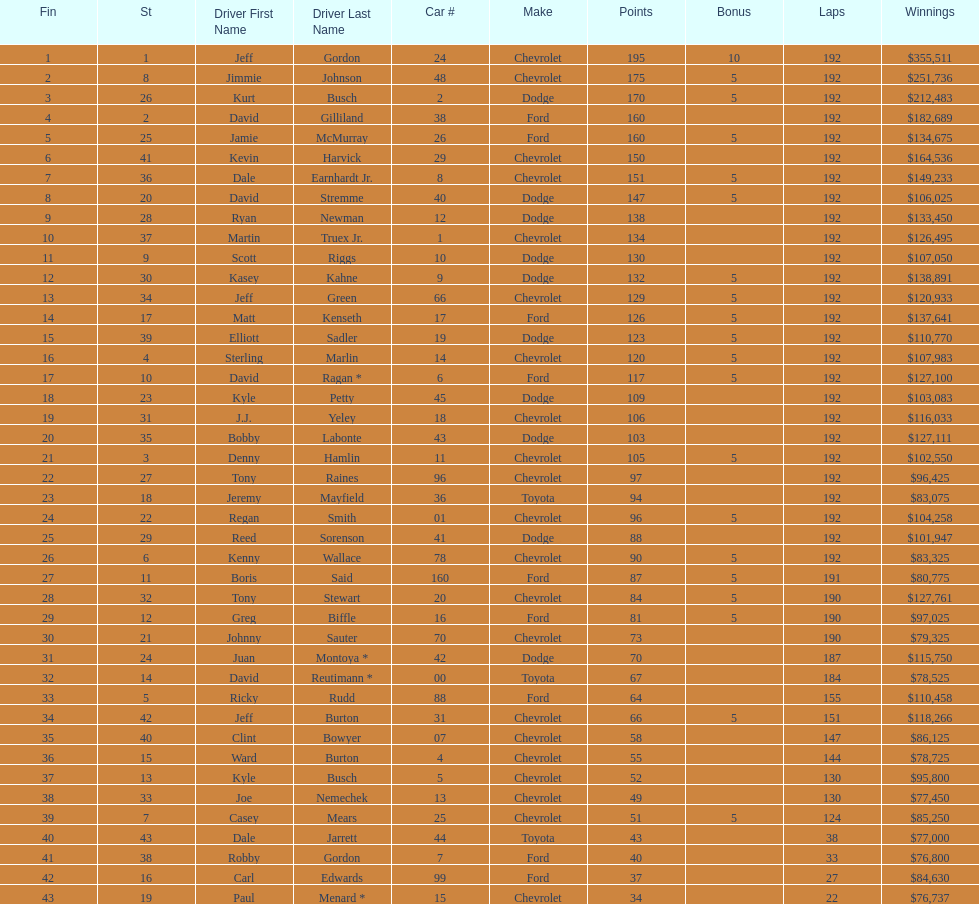How many race car drivers out of the 43 listed drove toyotas? 3. 